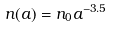Convert formula to latex. <formula><loc_0><loc_0><loc_500><loc_500>n ( a ) = n _ { 0 } a ^ { - 3 . 5 }</formula> 